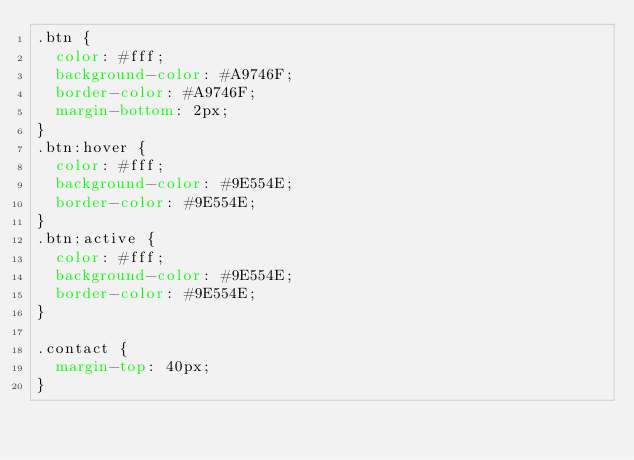Convert code to text. <code><loc_0><loc_0><loc_500><loc_500><_CSS_>.btn {
  color: #fff;
  background-color: #A9746F;
  border-color: #A9746F;
  margin-bottom: 2px;
}
.btn:hover {
  color: #fff;
  background-color: #9E554E;
  border-color: #9E554E;
}
.btn:active {
  color: #fff;
  background-color: #9E554E;
  border-color: #9E554E;
}

.contact {
  margin-top: 40px;
}</code> 